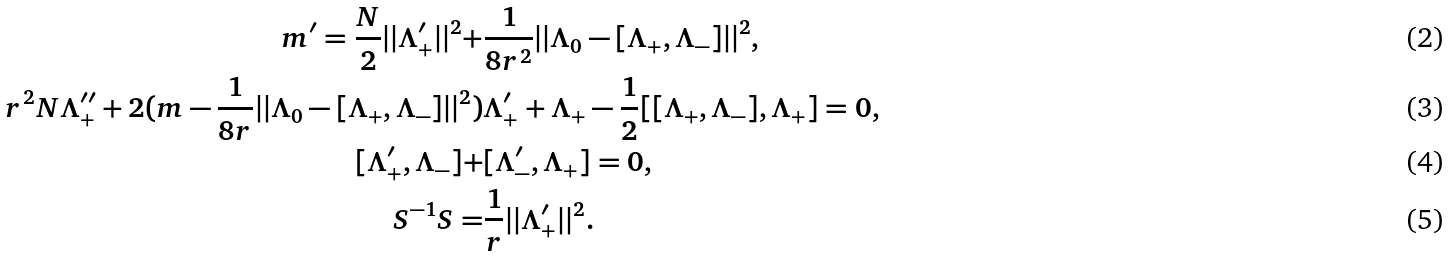<formula> <loc_0><loc_0><loc_500><loc_500>m ^ { \prime } = \frac { N } { 2 } | | \Lambda _ { + } ^ { \prime } | | ^ { 2 } + & \frac { 1 } { 8 r ^ { 2 } } | | \Lambda _ { 0 } - [ \Lambda _ { + } , \Lambda _ { - } ] | | ^ { 2 } , \\ r ^ { 2 } N \Lambda _ { + } ^ { \prime \prime } + 2 ( m - \frac { 1 } { 8 r } | | \Lambda _ { 0 } - [ \Lambda _ { + } , \Lambda _ { - } ] | | ^ { 2 } ) & \Lambda _ { + } ^ { \prime } + \Lambda _ { + } - \frac { 1 } { 2 } [ [ \Lambda _ { + } , \Lambda _ { - } ] , \Lambda _ { + } ] = 0 , \\ [ \Lambda _ { + } ^ { \prime } , \Lambda _ { - } ] + & [ \Lambda _ { - } ^ { \prime } , \Lambda _ { + } ] = 0 , \\ S ^ { - 1 } S = & \frac { 1 } { r } | | \Lambda _ { + } ^ { \prime } | | ^ { 2 } .</formula> 